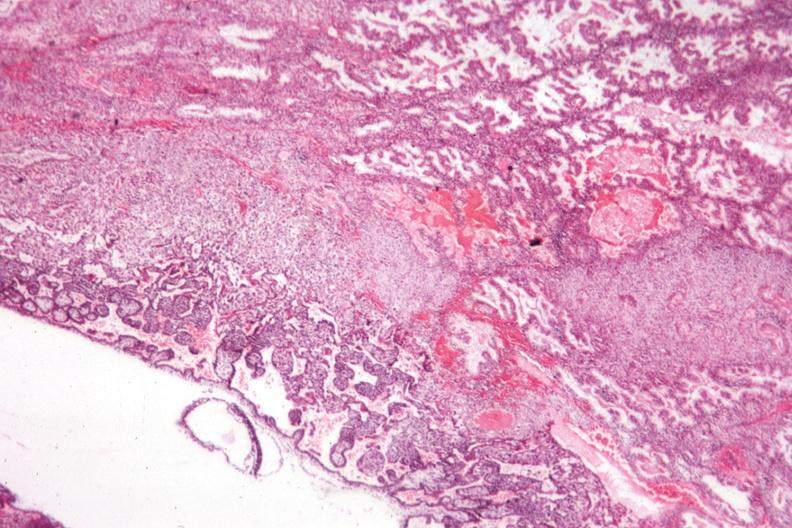what does this image show?
Answer the question using a single word or phrase. Shows early placental development 